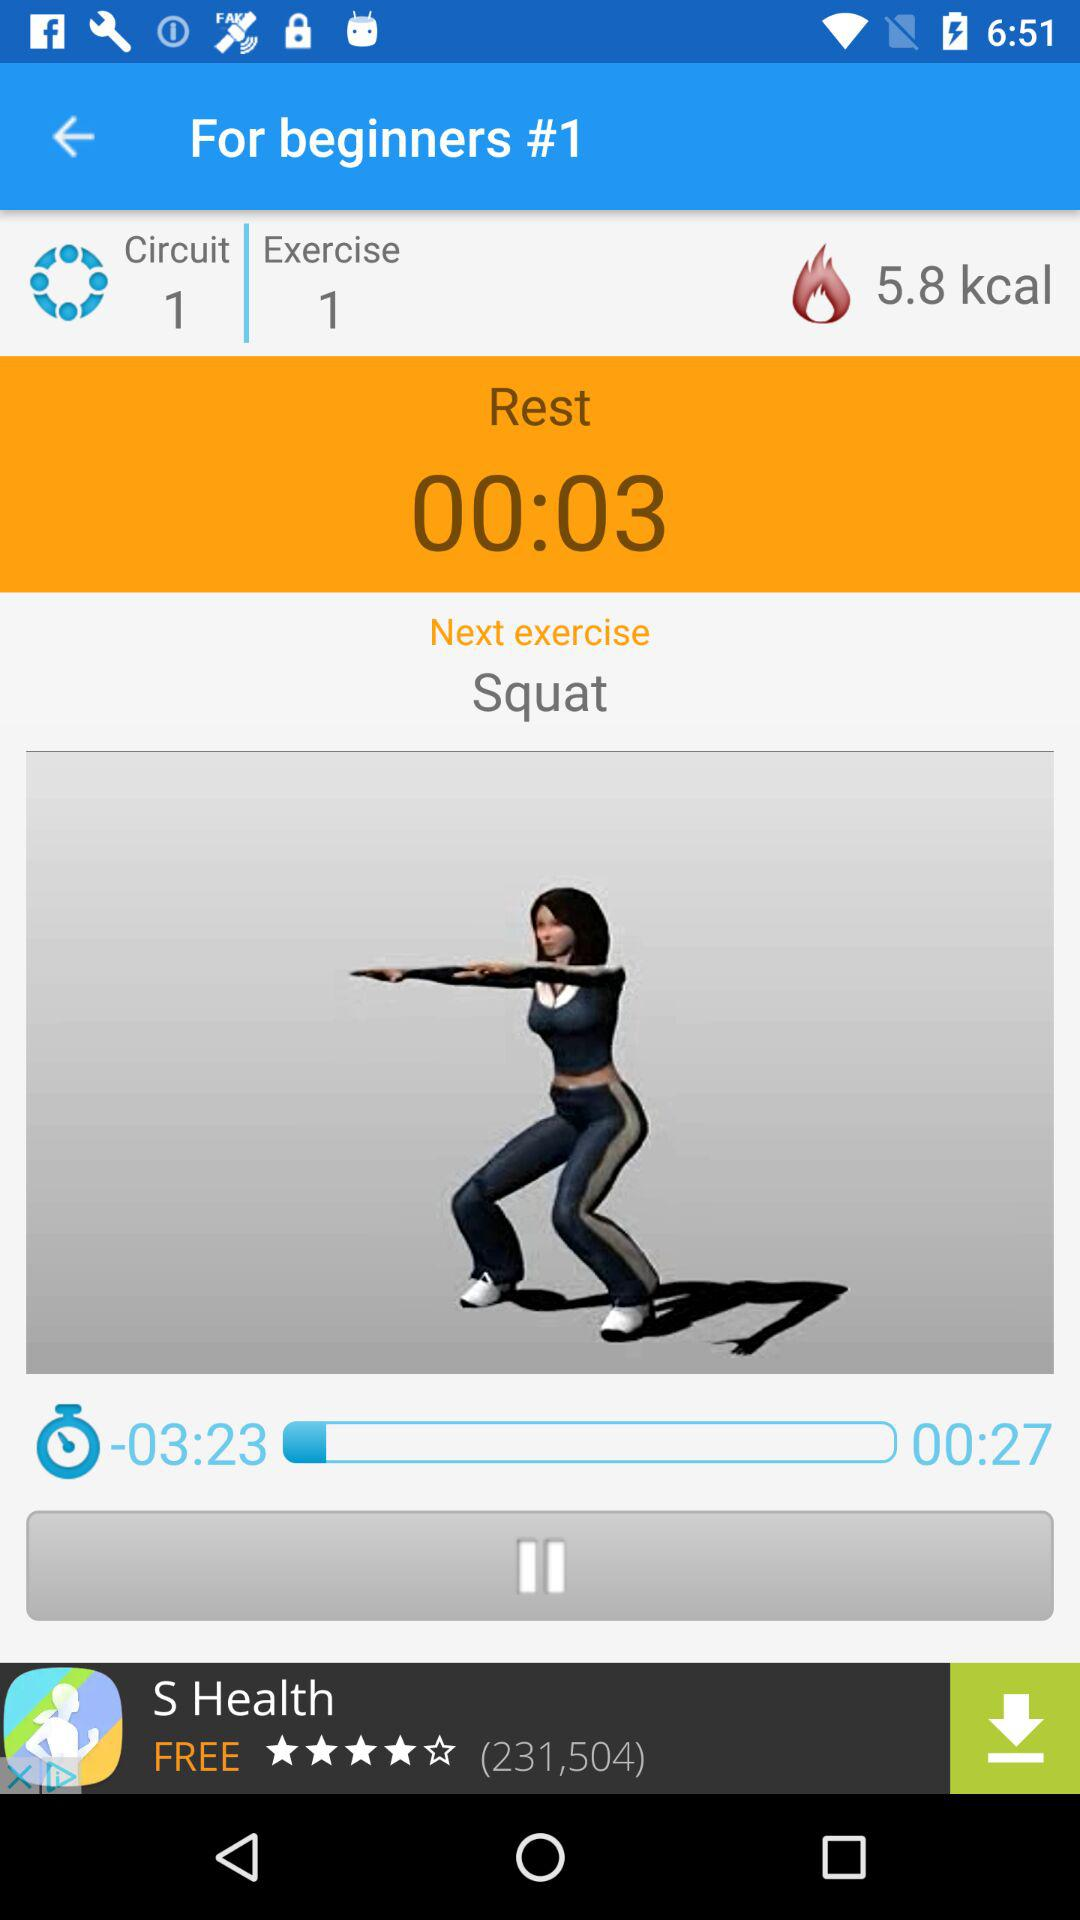What is the name of the next exercise? The name of the next exercise is squat. 